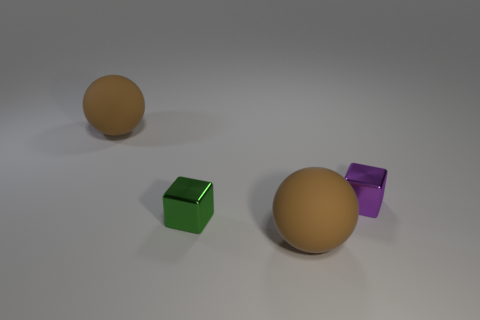How many blue things are either big matte things or shiny blocks?
Your answer should be compact. 0. How many other things are the same size as the green object?
Keep it short and to the point. 1. How many small cubes are there?
Offer a terse response. 2. Is there any other thing that has the same shape as the small purple metallic thing?
Your answer should be compact. Yes. Does the big ball that is in front of the green metal cube have the same material as the small cube behind the tiny green metallic thing?
Provide a succinct answer. No. What material is the green cube?
Your response must be concise. Metal. What number of small purple objects have the same material as the green thing?
Your answer should be very brief. 1. How many metal objects are either big objects or tiny green blocks?
Provide a short and direct response. 1. Does the small metal object that is in front of the purple metallic thing have the same shape as the big rubber thing behind the tiny purple thing?
Give a very brief answer. No. What is the color of the thing that is both right of the small green cube and behind the green metallic object?
Offer a very short reply. Purple. 